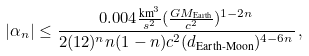<formula> <loc_0><loc_0><loc_500><loc_500>| \alpha _ { n } | \leq \frac { 0 . 0 0 4 \frac { \text {km} ^ { 3 } } { s ^ { 2 } } ( \frac { G M _ { \text {Earth} } } { c ^ { 2 } } ) ^ { 1 - 2 n } } { 2 ( 1 2 ) ^ { n } n ( 1 - n ) c ^ { 2 } ( d _ { \text {Earth-Moon} } ) ^ { 4 - 6 n } } \, ,</formula> 